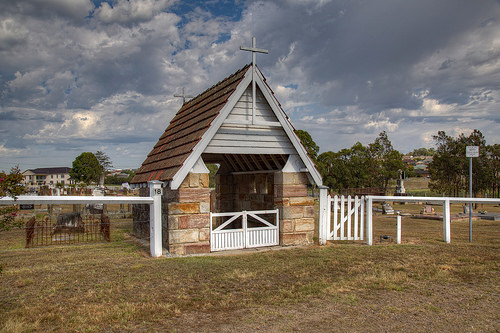<image>
Can you confirm if the house is on the land? Yes. Looking at the image, I can see the house is positioned on top of the land, with the land providing support. 